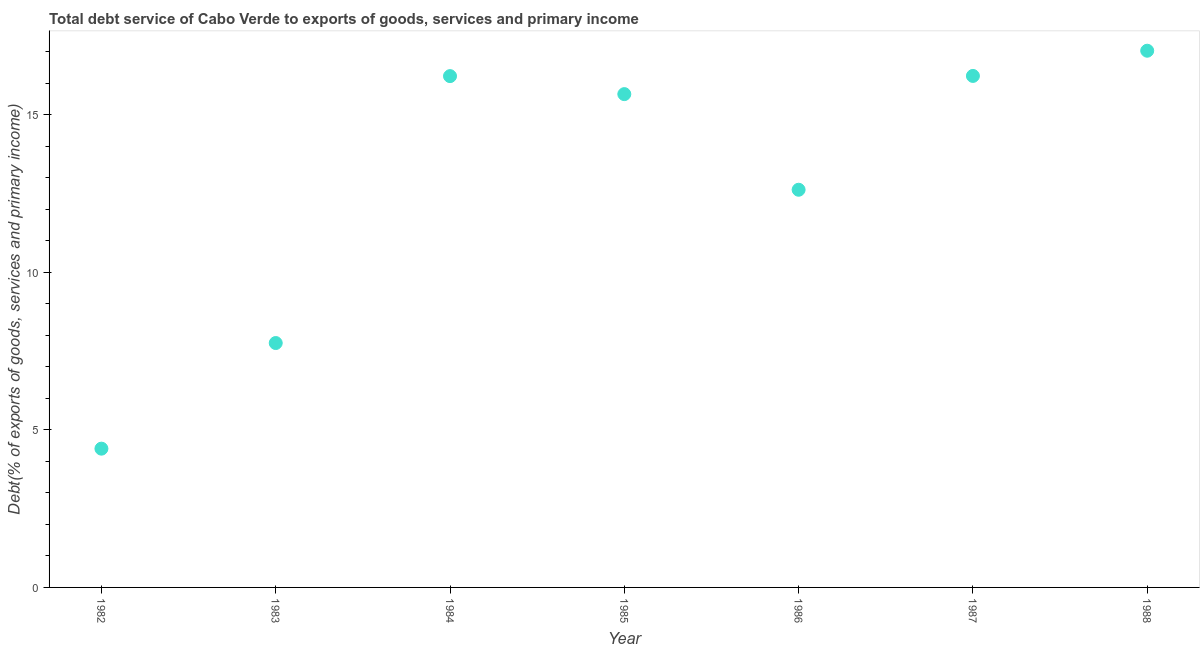What is the total debt service in 1986?
Make the answer very short. 12.62. Across all years, what is the maximum total debt service?
Your answer should be very brief. 17.03. Across all years, what is the minimum total debt service?
Your response must be concise. 4.4. In which year was the total debt service maximum?
Provide a short and direct response. 1988. What is the sum of the total debt service?
Keep it short and to the point. 89.92. What is the difference between the total debt service in 1982 and 1983?
Your answer should be compact. -3.35. What is the average total debt service per year?
Offer a very short reply. 12.85. What is the median total debt service?
Offer a very short reply. 15.65. What is the ratio of the total debt service in 1987 to that in 1988?
Make the answer very short. 0.95. Is the difference between the total debt service in 1985 and 1988 greater than the difference between any two years?
Ensure brevity in your answer.  No. What is the difference between the highest and the second highest total debt service?
Your answer should be very brief. 0.8. What is the difference between the highest and the lowest total debt service?
Your answer should be very brief. 12.63. In how many years, is the total debt service greater than the average total debt service taken over all years?
Provide a short and direct response. 4. Does the total debt service monotonically increase over the years?
Offer a very short reply. No. How many dotlines are there?
Provide a short and direct response. 1. What is the difference between two consecutive major ticks on the Y-axis?
Keep it short and to the point. 5. Does the graph contain any zero values?
Keep it short and to the point. No. What is the title of the graph?
Your response must be concise. Total debt service of Cabo Verde to exports of goods, services and primary income. What is the label or title of the X-axis?
Keep it short and to the point. Year. What is the label or title of the Y-axis?
Ensure brevity in your answer.  Debt(% of exports of goods, services and primary income). What is the Debt(% of exports of goods, services and primary income) in 1982?
Keep it short and to the point. 4.4. What is the Debt(% of exports of goods, services and primary income) in 1983?
Make the answer very short. 7.76. What is the Debt(% of exports of goods, services and primary income) in 1984?
Give a very brief answer. 16.22. What is the Debt(% of exports of goods, services and primary income) in 1985?
Your answer should be very brief. 15.65. What is the Debt(% of exports of goods, services and primary income) in 1986?
Provide a short and direct response. 12.62. What is the Debt(% of exports of goods, services and primary income) in 1987?
Provide a succinct answer. 16.23. What is the Debt(% of exports of goods, services and primary income) in 1988?
Provide a succinct answer. 17.03. What is the difference between the Debt(% of exports of goods, services and primary income) in 1982 and 1983?
Give a very brief answer. -3.35. What is the difference between the Debt(% of exports of goods, services and primary income) in 1982 and 1984?
Your response must be concise. -11.82. What is the difference between the Debt(% of exports of goods, services and primary income) in 1982 and 1985?
Keep it short and to the point. -11.25. What is the difference between the Debt(% of exports of goods, services and primary income) in 1982 and 1986?
Your answer should be compact. -8.22. What is the difference between the Debt(% of exports of goods, services and primary income) in 1982 and 1987?
Ensure brevity in your answer.  -11.83. What is the difference between the Debt(% of exports of goods, services and primary income) in 1982 and 1988?
Make the answer very short. -12.63. What is the difference between the Debt(% of exports of goods, services and primary income) in 1983 and 1984?
Your answer should be compact. -8.47. What is the difference between the Debt(% of exports of goods, services and primary income) in 1983 and 1985?
Offer a very short reply. -7.9. What is the difference between the Debt(% of exports of goods, services and primary income) in 1983 and 1986?
Provide a succinct answer. -4.86. What is the difference between the Debt(% of exports of goods, services and primary income) in 1983 and 1987?
Provide a short and direct response. -8.48. What is the difference between the Debt(% of exports of goods, services and primary income) in 1983 and 1988?
Your response must be concise. -9.28. What is the difference between the Debt(% of exports of goods, services and primary income) in 1984 and 1985?
Your answer should be very brief. 0.57. What is the difference between the Debt(% of exports of goods, services and primary income) in 1984 and 1986?
Keep it short and to the point. 3.61. What is the difference between the Debt(% of exports of goods, services and primary income) in 1984 and 1987?
Offer a very short reply. -0.01. What is the difference between the Debt(% of exports of goods, services and primary income) in 1984 and 1988?
Provide a short and direct response. -0.81. What is the difference between the Debt(% of exports of goods, services and primary income) in 1985 and 1986?
Give a very brief answer. 3.03. What is the difference between the Debt(% of exports of goods, services and primary income) in 1985 and 1987?
Make the answer very short. -0.58. What is the difference between the Debt(% of exports of goods, services and primary income) in 1985 and 1988?
Keep it short and to the point. -1.38. What is the difference between the Debt(% of exports of goods, services and primary income) in 1986 and 1987?
Your answer should be compact. -3.61. What is the difference between the Debt(% of exports of goods, services and primary income) in 1986 and 1988?
Provide a succinct answer. -4.41. What is the difference between the Debt(% of exports of goods, services and primary income) in 1987 and 1988?
Give a very brief answer. -0.8. What is the ratio of the Debt(% of exports of goods, services and primary income) in 1982 to that in 1983?
Give a very brief answer. 0.57. What is the ratio of the Debt(% of exports of goods, services and primary income) in 1982 to that in 1984?
Ensure brevity in your answer.  0.27. What is the ratio of the Debt(% of exports of goods, services and primary income) in 1982 to that in 1985?
Your answer should be compact. 0.28. What is the ratio of the Debt(% of exports of goods, services and primary income) in 1982 to that in 1986?
Keep it short and to the point. 0.35. What is the ratio of the Debt(% of exports of goods, services and primary income) in 1982 to that in 1987?
Offer a terse response. 0.27. What is the ratio of the Debt(% of exports of goods, services and primary income) in 1982 to that in 1988?
Offer a terse response. 0.26. What is the ratio of the Debt(% of exports of goods, services and primary income) in 1983 to that in 1984?
Make the answer very short. 0.48. What is the ratio of the Debt(% of exports of goods, services and primary income) in 1983 to that in 1985?
Give a very brief answer. 0.49. What is the ratio of the Debt(% of exports of goods, services and primary income) in 1983 to that in 1986?
Provide a short and direct response. 0.61. What is the ratio of the Debt(% of exports of goods, services and primary income) in 1983 to that in 1987?
Give a very brief answer. 0.48. What is the ratio of the Debt(% of exports of goods, services and primary income) in 1983 to that in 1988?
Your answer should be very brief. 0.46. What is the ratio of the Debt(% of exports of goods, services and primary income) in 1984 to that in 1985?
Give a very brief answer. 1.04. What is the ratio of the Debt(% of exports of goods, services and primary income) in 1984 to that in 1986?
Provide a succinct answer. 1.29. What is the ratio of the Debt(% of exports of goods, services and primary income) in 1984 to that in 1988?
Give a very brief answer. 0.95. What is the ratio of the Debt(% of exports of goods, services and primary income) in 1985 to that in 1986?
Your answer should be very brief. 1.24. What is the ratio of the Debt(% of exports of goods, services and primary income) in 1985 to that in 1987?
Offer a very short reply. 0.96. What is the ratio of the Debt(% of exports of goods, services and primary income) in 1985 to that in 1988?
Ensure brevity in your answer.  0.92. What is the ratio of the Debt(% of exports of goods, services and primary income) in 1986 to that in 1987?
Your answer should be compact. 0.78. What is the ratio of the Debt(% of exports of goods, services and primary income) in 1986 to that in 1988?
Make the answer very short. 0.74. What is the ratio of the Debt(% of exports of goods, services and primary income) in 1987 to that in 1988?
Offer a terse response. 0.95. 